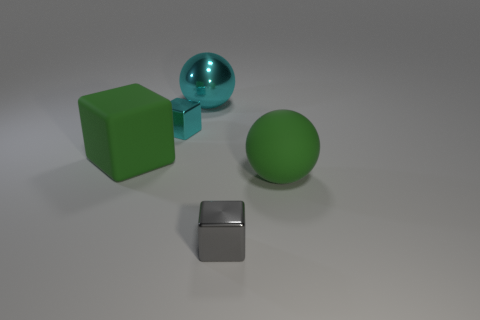There is a thing that is the same color as the big metallic sphere; what shape is it?
Your answer should be very brief. Cube. There is a metal cube that is the same color as the large shiny object; what size is it?
Give a very brief answer. Small. There is a big green object that is the same shape as the small gray metallic object; what material is it?
Ensure brevity in your answer.  Rubber. How many blocks have the same size as the rubber sphere?
Ensure brevity in your answer.  1. How many tiny cyan shiny objects are there?
Provide a short and direct response. 1. Is the tiny cyan object made of the same material as the ball on the left side of the gray object?
Keep it short and to the point. Yes. How many blue objects are either balls or large shiny objects?
Keep it short and to the point. 0. The cyan object that is the same material as the cyan sphere is what size?
Your response must be concise. Small. How many other metal objects are the same shape as the large cyan metallic object?
Your answer should be very brief. 0. Are there more gray things that are on the right side of the large cube than big green objects on the left side of the cyan metal ball?
Offer a very short reply. No. 